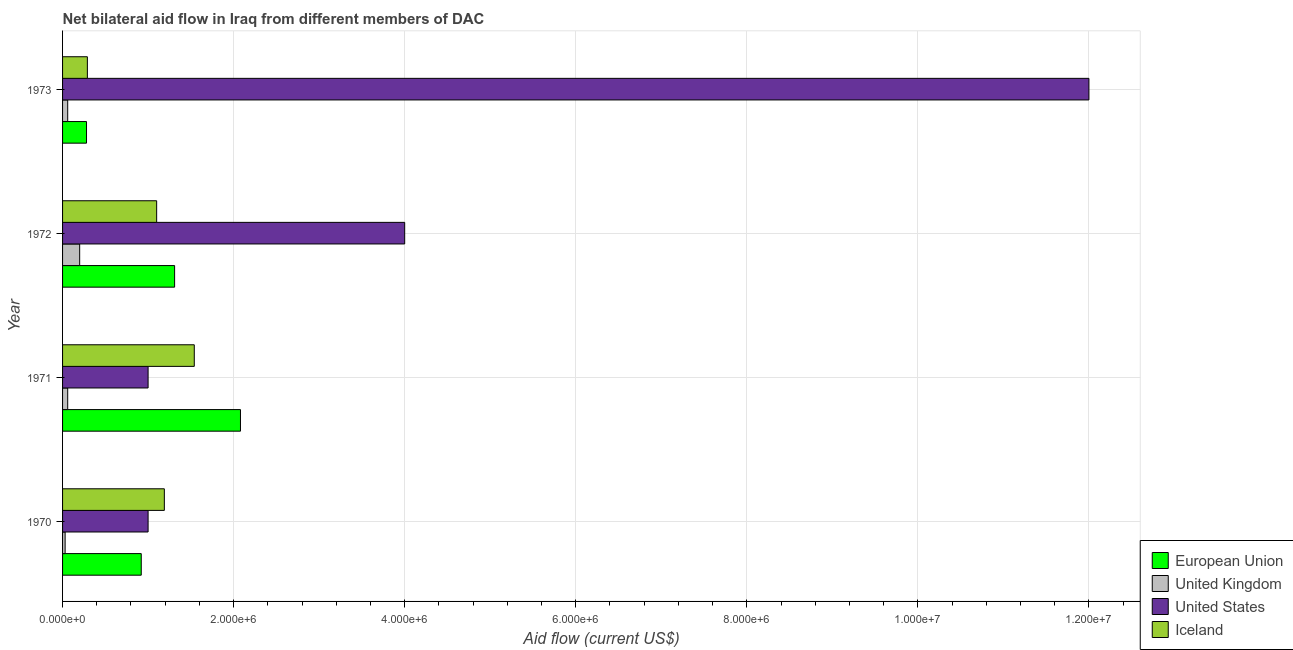How many different coloured bars are there?
Your answer should be very brief. 4. Are the number of bars per tick equal to the number of legend labels?
Keep it short and to the point. Yes. What is the label of the 4th group of bars from the top?
Keep it short and to the point. 1970. In how many cases, is the number of bars for a given year not equal to the number of legend labels?
Keep it short and to the point. 0. What is the amount of aid given by uk in 1971?
Offer a very short reply. 6.00e+04. Across all years, what is the maximum amount of aid given by uk?
Offer a terse response. 2.00e+05. Across all years, what is the minimum amount of aid given by iceland?
Your answer should be very brief. 2.90e+05. What is the total amount of aid given by us in the graph?
Your answer should be very brief. 1.80e+07. What is the difference between the amount of aid given by uk in 1972 and that in 1973?
Offer a terse response. 1.40e+05. What is the difference between the amount of aid given by iceland in 1972 and the amount of aid given by uk in 1971?
Offer a terse response. 1.04e+06. What is the average amount of aid given by uk per year?
Your response must be concise. 8.75e+04. In the year 1972, what is the difference between the amount of aid given by uk and amount of aid given by eu?
Give a very brief answer. -1.11e+06. In how many years, is the amount of aid given by iceland greater than 9600000 US$?
Offer a terse response. 0. What is the ratio of the amount of aid given by eu in 1970 to that in 1973?
Keep it short and to the point. 3.29. Is the difference between the amount of aid given by eu in 1971 and 1972 greater than the difference between the amount of aid given by iceland in 1971 and 1972?
Provide a short and direct response. Yes. What is the difference between the highest and the lowest amount of aid given by eu?
Offer a terse response. 1.80e+06. How many bars are there?
Ensure brevity in your answer.  16. Are all the bars in the graph horizontal?
Your answer should be very brief. Yes. How many legend labels are there?
Your response must be concise. 4. What is the title of the graph?
Offer a very short reply. Net bilateral aid flow in Iraq from different members of DAC. Does "Primary schools" appear as one of the legend labels in the graph?
Provide a succinct answer. No. What is the Aid flow (current US$) of European Union in 1970?
Ensure brevity in your answer.  9.20e+05. What is the Aid flow (current US$) in United Kingdom in 1970?
Your answer should be compact. 3.00e+04. What is the Aid flow (current US$) of Iceland in 1970?
Ensure brevity in your answer.  1.19e+06. What is the Aid flow (current US$) of European Union in 1971?
Keep it short and to the point. 2.08e+06. What is the Aid flow (current US$) in Iceland in 1971?
Give a very brief answer. 1.54e+06. What is the Aid flow (current US$) in European Union in 1972?
Provide a succinct answer. 1.31e+06. What is the Aid flow (current US$) in United Kingdom in 1972?
Make the answer very short. 2.00e+05. What is the Aid flow (current US$) in United States in 1972?
Offer a very short reply. 4.00e+06. What is the Aid flow (current US$) in Iceland in 1972?
Keep it short and to the point. 1.10e+06. What is the Aid flow (current US$) in United States in 1973?
Ensure brevity in your answer.  1.20e+07. What is the Aid flow (current US$) of Iceland in 1973?
Offer a terse response. 2.90e+05. Across all years, what is the maximum Aid flow (current US$) in European Union?
Offer a very short reply. 2.08e+06. Across all years, what is the maximum Aid flow (current US$) in United Kingdom?
Your response must be concise. 2.00e+05. Across all years, what is the maximum Aid flow (current US$) in Iceland?
Your answer should be compact. 1.54e+06. Across all years, what is the minimum Aid flow (current US$) in European Union?
Provide a short and direct response. 2.80e+05. Across all years, what is the minimum Aid flow (current US$) in United Kingdom?
Offer a very short reply. 3.00e+04. Across all years, what is the minimum Aid flow (current US$) in United States?
Offer a very short reply. 1.00e+06. Across all years, what is the minimum Aid flow (current US$) of Iceland?
Keep it short and to the point. 2.90e+05. What is the total Aid flow (current US$) in European Union in the graph?
Provide a short and direct response. 4.59e+06. What is the total Aid flow (current US$) in United Kingdom in the graph?
Provide a short and direct response. 3.50e+05. What is the total Aid flow (current US$) in United States in the graph?
Offer a terse response. 1.80e+07. What is the total Aid flow (current US$) of Iceland in the graph?
Your answer should be very brief. 4.12e+06. What is the difference between the Aid flow (current US$) in European Union in 1970 and that in 1971?
Offer a very short reply. -1.16e+06. What is the difference between the Aid flow (current US$) of Iceland in 1970 and that in 1971?
Give a very brief answer. -3.50e+05. What is the difference between the Aid flow (current US$) in European Union in 1970 and that in 1972?
Offer a very short reply. -3.90e+05. What is the difference between the Aid flow (current US$) in United States in 1970 and that in 1972?
Offer a very short reply. -3.00e+06. What is the difference between the Aid flow (current US$) in Iceland in 1970 and that in 1972?
Give a very brief answer. 9.00e+04. What is the difference between the Aid flow (current US$) in European Union in 1970 and that in 1973?
Provide a short and direct response. 6.40e+05. What is the difference between the Aid flow (current US$) in United Kingdom in 1970 and that in 1973?
Your response must be concise. -3.00e+04. What is the difference between the Aid flow (current US$) in United States in 1970 and that in 1973?
Your response must be concise. -1.10e+07. What is the difference between the Aid flow (current US$) in Iceland in 1970 and that in 1973?
Offer a terse response. 9.00e+05. What is the difference between the Aid flow (current US$) of European Union in 1971 and that in 1972?
Offer a very short reply. 7.70e+05. What is the difference between the Aid flow (current US$) in United Kingdom in 1971 and that in 1972?
Offer a very short reply. -1.40e+05. What is the difference between the Aid flow (current US$) of European Union in 1971 and that in 1973?
Ensure brevity in your answer.  1.80e+06. What is the difference between the Aid flow (current US$) of United Kingdom in 1971 and that in 1973?
Provide a succinct answer. 0. What is the difference between the Aid flow (current US$) in United States in 1971 and that in 1973?
Ensure brevity in your answer.  -1.10e+07. What is the difference between the Aid flow (current US$) of Iceland in 1971 and that in 1973?
Make the answer very short. 1.25e+06. What is the difference between the Aid flow (current US$) in European Union in 1972 and that in 1973?
Give a very brief answer. 1.03e+06. What is the difference between the Aid flow (current US$) of United Kingdom in 1972 and that in 1973?
Your response must be concise. 1.40e+05. What is the difference between the Aid flow (current US$) of United States in 1972 and that in 1973?
Offer a very short reply. -8.00e+06. What is the difference between the Aid flow (current US$) of Iceland in 1972 and that in 1973?
Your response must be concise. 8.10e+05. What is the difference between the Aid flow (current US$) in European Union in 1970 and the Aid flow (current US$) in United Kingdom in 1971?
Your answer should be very brief. 8.60e+05. What is the difference between the Aid flow (current US$) of European Union in 1970 and the Aid flow (current US$) of Iceland in 1971?
Provide a succinct answer. -6.20e+05. What is the difference between the Aid flow (current US$) of United Kingdom in 1970 and the Aid flow (current US$) of United States in 1971?
Keep it short and to the point. -9.70e+05. What is the difference between the Aid flow (current US$) in United Kingdom in 1970 and the Aid flow (current US$) in Iceland in 1971?
Provide a succinct answer. -1.51e+06. What is the difference between the Aid flow (current US$) in United States in 1970 and the Aid flow (current US$) in Iceland in 1971?
Your response must be concise. -5.40e+05. What is the difference between the Aid flow (current US$) in European Union in 1970 and the Aid flow (current US$) in United Kingdom in 1972?
Ensure brevity in your answer.  7.20e+05. What is the difference between the Aid flow (current US$) of European Union in 1970 and the Aid flow (current US$) of United States in 1972?
Give a very brief answer. -3.08e+06. What is the difference between the Aid flow (current US$) in European Union in 1970 and the Aid flow (current US$) in Iceland in 1972?
Your answer should be very brief. -1.80e+05. What is the difference between the Aid flow (current US$) of United Kingdom in 1970 and the Aid flow (current US$) of United States in 1972?
Provide a succinct answer. -3.97e+06. What is the difference between the Aid flow (current US$) in United Kingdom in 1970 and the Aid flow (current US$) in Iceland in 1972?
Ensure brevity in your answer.  -1.07e+06. What is the difference between the Aid flow (current US$) of United States in 1970 and the Aid flow (current US$) of Iceland in 1972?
Provide a short and direct response. -1.00e+05. What is the difference between the Aid flow (current US$) of European Union in 1970 and the Aid flow (current US$) of United Kingdom in 1973?
Your answer should be very brief. 8.60e+05. What is the difference between the Aid flow (current US$) in European Union in 1970 and the Aid flow (current US$) in United States in 1973?
Give a very brief answer. -1.11e+07. What is the difference between the Aid flow (current US$) in European Union in 1970 and the Aid flow (current US$) in Iceland in 1973?
Keep it short and to the point. 6.30e+05. What is the difference between the Aid flow (current US$) of United Kingdom in 1970 and the Aid flow (current US$) of United States in 1973?
Provide a short and direct response. -1.20e+07. What is the difference between the Aid flow (current US$) in United States in 1970 and the Aid flow (current US$) in Iceland in 1973?
Offer a terse response. 7.10e+05. What is the difference between the Aid flow (current US$) in European Union in 1971 and the Aid flow (current US$) in United Kingdom in 1972?
Give a very brief answer. 1.88e+06. What is the difference between the Aid flow (current US$) of European Union in 1971 and the Aid flow (current US$) of United States in 1972?
Give a very brief answer. -1.92e+06. What is the difference between the Aid flow (current US$) of European Union in 1971 and the Aid flow (current US$) of Iceland in 1972?
Ensure brevity in your answer.  9.80e+05. What is the difference between the Aid flow (current US$) of United Kingdom in 1971 and the Aid flow (current US$) of United States in 1972?
Give a very brief answer. -3.94e+06. What is the difference between the Aid flow (current US$) of United Kingdom in 1971 and the Aid flow (current US$) of Iceland in 1972?
Your answer should be very brief. -1.04e+06. What is the difference between the Aid flow (current US$) in United States in 1971 and the Aid flow (current US$) in Iceland in 1972?
Keep it short and to the point. -1.00e+05. What is the difference between the Aid flow (current US$) in European Union in 1971 and the Aid flow (current US$) in United Kingdom in 1973?
Provide a succinct answer. 2.02e+06. What is the difference between the Aid flow (current US$) of European Union in 1971 and the Aid flow (current US$) of United States in 1973?
Ensure brevity in your answer.  -9.92e+06. What is the difference between the Aid flow (current US$) in European Union in 1971 and the Aid flow (current US$) in Iceland in 1973?
Your response must be concise. 1.79e+06. What is the difference between the Aid flow (current US$) in United Kingdom in 1971 and the Aid flow (current US$) in United States in 1973?
Keep it short and to the point. -1.19e+07. What is the difference between the Aid flow (current US$) of United Kingdom in 1971 and the Aid flow (current US$) of Iceland in 1973?
Offer a terse response. -2.30e+05. What is the difference between the Aid flow (current US$) of United States in 1971 and the Aid flow (current US$) of Iceland in 1973?
Offer a terse response. 7.10e+05. What is the difference between the Aid flow (current US$) of European Union in 1972 and the Aid flow (current US$) of United Kingdom in 1973?
Provide a short and direct response. 1.25e+06. What is the difference between the Aid flow (current US$) in European Union in 1972 and the Aid flow (current US$) in United States in 1973?
Offer a very short reply. -1.07e+07. What is the difference between the Aid flow (current US$) of European Union in 1972 and the Aid flow (current US$) of Iceland in 1973?
Provide a short and direct response. 1.02e+06. What is the difference between the Aid flow (current US$) of United Kingdom in 1972 and the Aid flow (current US$) of United States in 1973?
Your answer should be compact. -1.18e+07. What is the difference between the Aid flow (current US$) of United Kingdom in 1972 and the Aid flow (current US$) of Iceland in 1973?
Provide a short and direct response. -9.00e+04. What is the difference between the Aid flow (current US$) of United States in 1972 and the Aid flow (current US$) of Iceland in 1973?
Offer a terse response. 3.71e+06. What is the average Aid flow (current US$) in European Union per year?
Offer a terse response. 1.15e+06. What is the average Aid flow (current US$) in United Kingdom per year?
Ensure brevity in your answer.  8.75e+04. What is the average Aid flow (current US$) in United States per year?
Offer a very short reply. 4.50e+06. What is the average Aid flow (current US$) of Iceland per year?
Provide a short and direct response. 1.03e+06. In the year 1970, what is the difference between the Aid flow (current US$) in European Union and Aid flow (current US$) in United Kingdom?
Give a very brief answer. 8.90e+05. In the year 1970, what is the difference between the Aid flow (current US$) of European Union and Aid flow (current US$) of United States?
Offer a very short reply. -8.00e+04. In the year 1970, what is the difference between the Aid flow (current US$) of European Union and Aid flow (current US$) of Iceland?
Your answer should be compact. -2.70e+05. In the year 1970, what is the difference between the Aid flow (current US$) of United Kingdom and Aid flow (current US$) of United States?
Ensure brevity in your answer.  -9.70e+05. In the year 1970, what is the difference between the Aid flow (current US$) in United Kingdom and Aid flow (current US$) in Iceland?
Provide a succinct answer. -1.16e+06. In the year 1970, what is the difference between the Aid flow (current US$) of United States and Aid flow (current US$) of Iceland?
Offer a very short reply. -1.90e+05. In the year 1971, what is the difference between the Aid flow (current US$) in European Union and Aid flow (current US$) in United Kingdom?
Your answer should be compact. 2.02e+06. In the year 1971, what is the difference between the Aid flow (current US$) in European Union and Aid flow (current US$) in United States?
Offer a very short reply. 1.08e+06. In the year 1971, what is the difference between the Aid flow (current US$) in European Union and Aid flow (current US$) in Iceland?
Offer a terse response. 5.40e+05. In the year 1971, what is the difference between the Aid flow (current US$) of United Kingdom and Aid flow (current US$) of United States?
Provide a succinct answer. -9.40e+05. In the year 1971, what is the difference between the Aid flow (current US$) of United Kingdom and Aid flow (current US$) of Iceland?
Give a very brief answer. -1.48e+06. In the year 1971, what is the difference between the Aid flow (current US$) in United States and Aid flow (current US$) in Iceland?
Your answer should be compact. -5.40e+05. In the year 1972, what is the difference between the Aid flow (current US$) of European Union and Aid flow (current US$) of United Kingdom?
Give a very brief answer. 1.11e+06. In the year 1972, what is the difference between the Aid flow (current US$) in European Union and Aid flow (current US$) in United States?
Offer a terse response. -2.69e+06. In the year 1972, what is the difference between the Aid flow (current US$) of European Union and Aid flow (current US$) of Iceland?
Provide a short and direct response. 2.10e+05. In the year 1972, what is the difference between the Aid flow (current US$) in United Kingdom and Aid flow (current US$) in United States?
Your response must be concise. -3.80e+06. In the year 1972, what is the difference between the Aid flow (current US$) in United Kingdom and Aid flow (current US$) in Iceland?
Keep it short and to the point. -9.00e+05. In the year 1972, what is the difference between the Aid flow (current US$) in United States and Aid flow (current US$) in Iceland?
Your response must be concise. 2.90e+06. In the year 1973, what is the difference between the Aid flow (current US$) in European Union and Aid flow (current US$) in United States?
Your answer should be compact. -1.17e+07. In the year 1973, what is the difference between the Aid flow (current US$) of United Kingdom and Aid flow (current US$) of United States?
Ensure brevity in your answer.  -1.19e+07. In the year 1973, what is the difference between the Aid flow (current US$) of United States and Aid flow (current US$) of Iceland?
Give a very brief answer. 1.17e+07. What is the ratio of the Aid flow (current US$) in European Union in 1970 to that in 1971?
Keep it short and to the point. 0.44. What is the ratio of the Aid flow (current US$) of Iceland in 1970 to that in 1971?
Your answer should be compact. 0.77. What is the ratio of the Aid flow (current US$) in European Union in 1970 to that in 1972?
Give a very brief answer. 0.7. What is the ratio of the Aid flow (current US$) in United Kingdom in 1970 to that in 1972?
Provide a succinct answer. 0.15. What is the ratio of the Aid flow (current US$) of Iceland in 1970 to that in 1972?
Keep it short and to the point. 1.08. What is the ratio of the Aid flow (current US$) in European Union in 1970 to that in 1973?
Offer a very short reply. 3.29. What is the ratio of the Aid flow (current US$) of United States in 1970 to that in 1973?
Ensure brevity in your answer.  0.08. What is the ratio of the Aid flow (current US$) in Iceland in 1970 to that in 1973?
Make the answer very short. 4.1. What is the ratio of the Aid flow (current US$) of European Union in 1971 to that in 1972?
Provide a short and direct response. 1.59. What is the ratio of the Aid flow (current US$) of European Union in 1971 to that in 1973?
Offer a terse response. 7.43. What is the ratio of the Aid flow (current US$) in United States in 1971 to that in 1973?
Make the answer very short. 0.08. What is the ratio of the Aid flow (current US$) in Iceland in 1971 to that in 1973?
Ensure brevity in your answer.  5.31. What is the ratio of the Aid flow (current US$) of European Union in 1972 to that in 1973?
Provide a succinct answer. 4.68. What is the ratio of the Aid flow (current US$) of United States in 1972 to that in 1973?
Provide a short and direct response. 0.33. What is the ratio of the Aid flow (current US$) in Iceland in 1972 to that in 1973?
Offer a very short reply. 3.79. What is the difference between the highest and the second highest Aid flow (current US$) of European Union?
Provide a succinct answer. 7.70e+05. What is the difference between the highest and the second highest Aid flow (current US$) of United States?
Your answer should be compact. 8.00e+06. What is the difference between the highest and the second highest Aid flow (current US$) in Iceland?
Provide a short and direct response. 3.50e+05. What is the difference between the highest and the lowest Aid flow (current US$) of European Union?
Your response must be concise. 1.80e+06. What is the difference between the highest and the lowest Aid flow (current US$) in United Kingdom?
Offer a terse response. 1.70e+05. What is the difference between the highest and the lowest Aid flow (current US$) in United States?
Provide a succinct answer. 1.10e+07. What is the difference between the highest and the lowest Aid flow (current US$) in Iceland?
Offer a very short reply. 1.25e+06. 